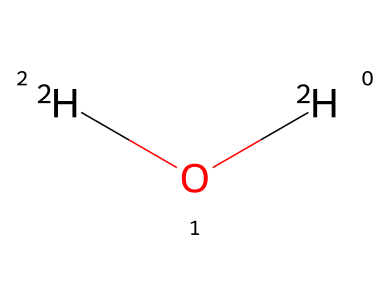What is the name of this chemical? The SMILES representation indicates a molecule with two hydrogen isotopes and one oxygen atom, which is commonly known as heavy water.
Answer: heavy water How many hydrogen atoms are present in this molecule? The SMILES notation shows [2H]O[2H], indicating two deuterium hydrogen atoms, which means there are two hydrogen atoms.
Answer: 2 What is the molecular formula of this chemical? By interpreting the SMILES, we see there are two deuterium atoms (D) and one oxygen atom (O), leading to the molecular formula D2O.
Answer: D2O Which property of heavy water affects its density compared to regular water? The presence of deuterium instead of regular hydrogen increases the mass of water, thereby increasing the density of heavy water beyond that of regular water.
Answer: density How does heavy water influence cognitive function in studies? Research suggests that heavy water can affect biochemical processes due to its unique hydrogen isotopes, potentially impacting cellular functions and cognition in animals or cells.
Answer: affects cognition What type of bonds are present in this molecular structure? The structure represents a covalent bond between the deuterium atoms and the oxygen atom, characteristic of water molecules.
Answer: covalent bonds How does the molecular structure of heavy water differ from regular water? The key difference lies in the isotopic composition, where heavy water contains deuterium (a heavier isotope of hydrogen) instead of protium (the most common hydrogen isotope) found in regular water.
Answer: isotopic composition 